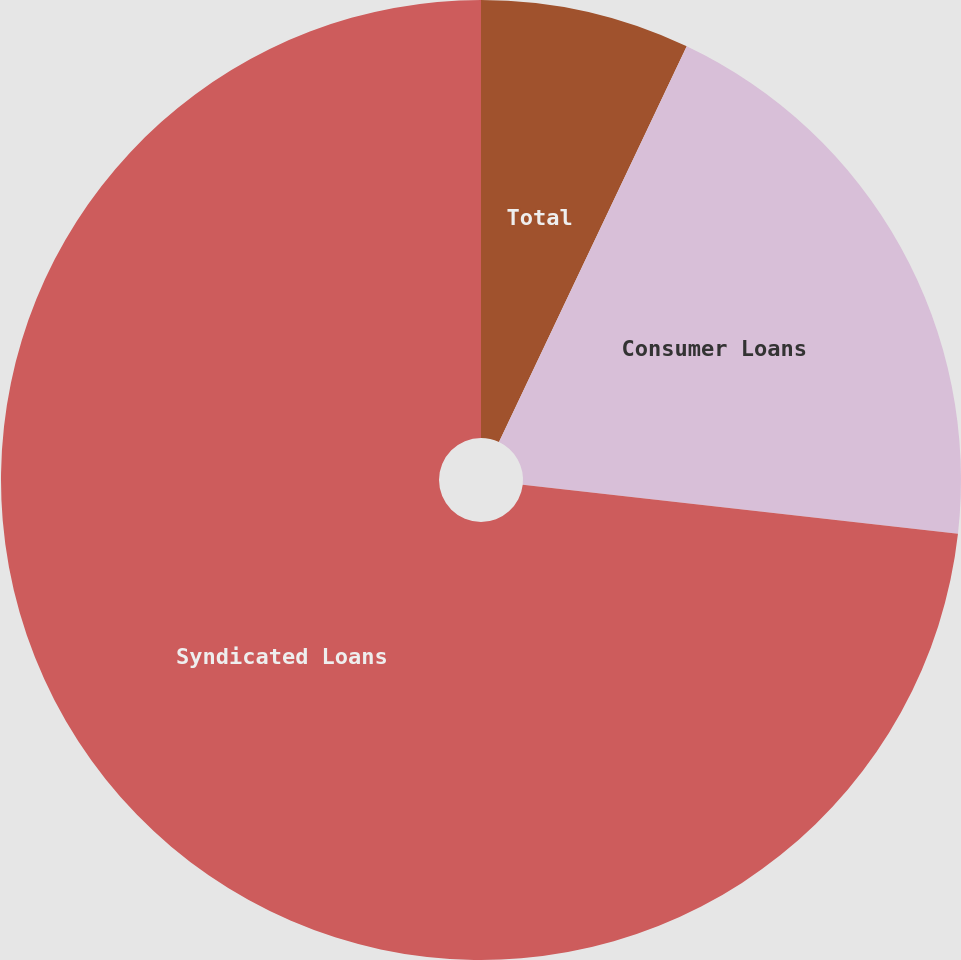<chart> <loc_0><loc_0><loc_500><loc_500><pie_chart><fcel>Total<fcel>Consumer Loans<fcel>Syndicated Loans<nl><fcel>7.05%<fcel>19.74%<fcel>73.21%<nl></chart> 